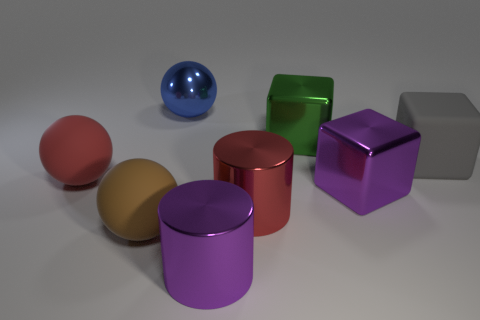Add 2 large gray matte cubes. How many objects exist? 10 Subtract all cylinders. How many objects are left? 6 Add 8 red cylinders. How many red cylinders are left? 9 Add 1 green metallic balls. How many green metallic balls exist? 1 Subtract 0 cyan cylinders. How many objects are left? 8 Subtract all big brown shiny cylinders. Subtract all red rubber spheres. How many objects are left? 7 